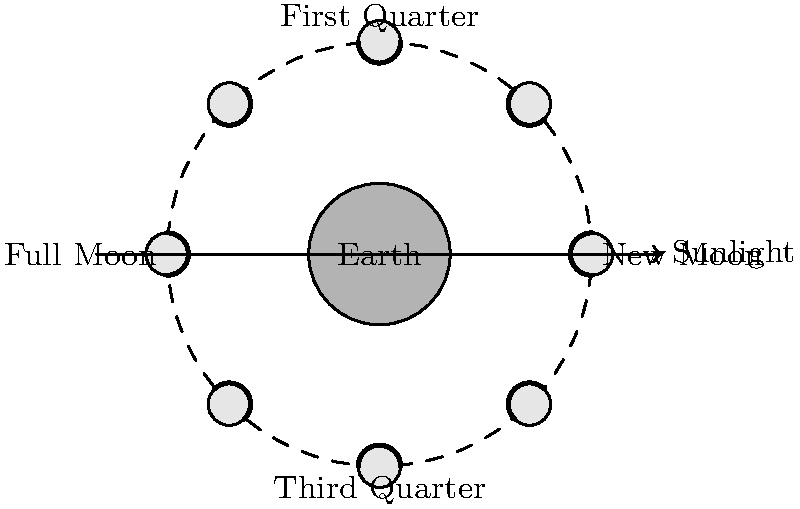Oh, darling, as I gaze upon my collection of vintage brooches, I can't help but wonder about the cosmic ballet above. Can you enlighten me on which phase of the moon would cast the most ethereal glow on my delicate jewelry? Is it when the illuminated portion is increasing or decreasing? Let's unravel this cosmic mystery step by step, my dear:

1. The moon's phases are determined by its position relative to the Earth and Sun.

2. The illuminated portion of the moon visible from Earth changes as it orbits:
   - New Moon: 0% illuminated (dark)
   - Waxing Crescent: 0-50% illuminated, increasing
   - First Quarter: 50% illuminated, right half visible
   - Waxing Gibbous: 50-100% illuminated, increasing
   - Full Moon: 100% illuminated
   - Waning Gibbous: 100-50% illuminated, decreasing
   - Third Quarter: 50% illuminated, left half visible
   - Waning Crescent: 50-0% illuminated, decreasing

3. The Full Moon phase provides the most illumination on Earth, as the entire visible surface reflects sunlight.

4. However, the "most ethereal glow" is subjective and might be associated with the Waxing Gibbous phase:
   - It's nearly full, providing significant illumination
   - The slight incompleteness adds a touch of mystery
   - The increasing illumination symbolizes growth and potential

5. The illuminated portion is increasing during the Waxing phases (Crescent, First Quarter, and Gibbous).

Therefore, the Waxing Gibbous phase, when the illuminated portion is increasing, would likely cast the most ethereal glow on your delicate jewelry.
Answer: Waxing Gibbous 